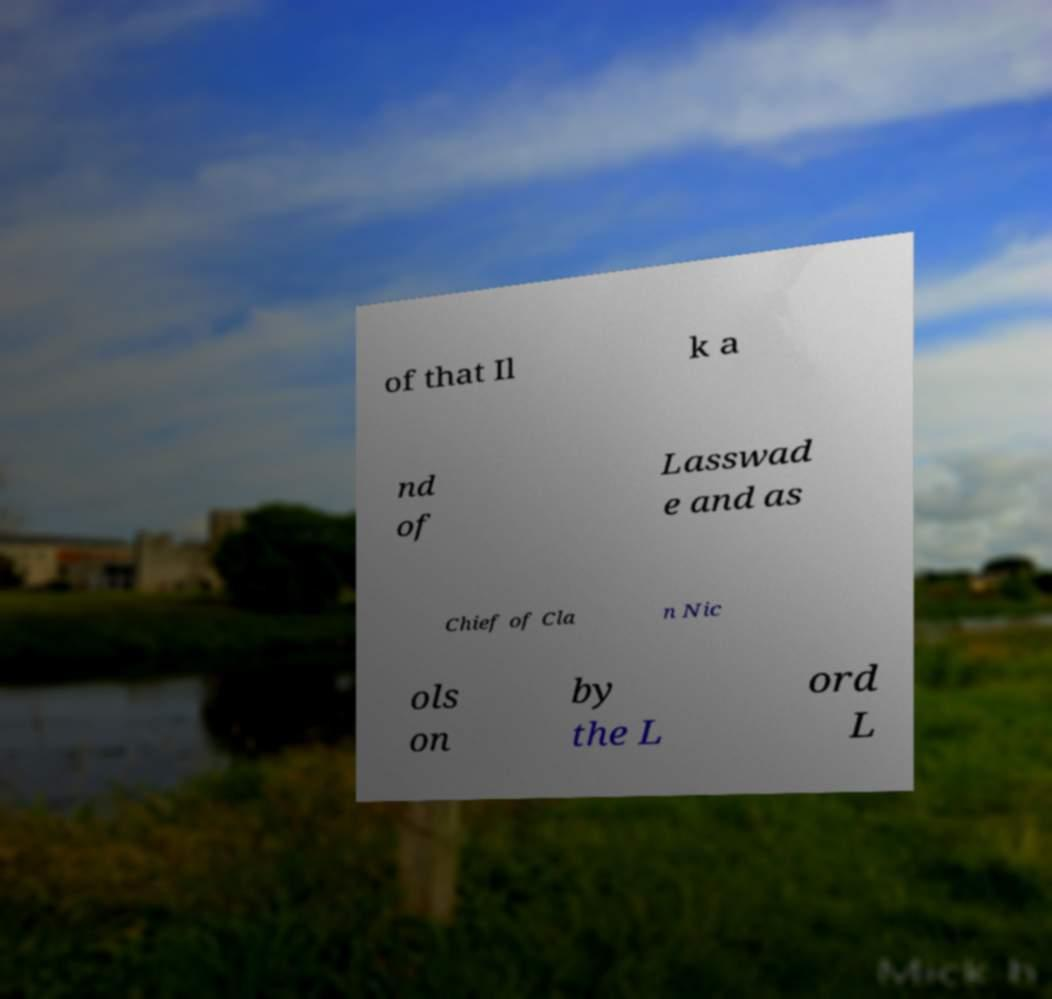I need the written content from this picture converted into text. Can you do that? of that Il k a nd of Lasswad e and as Chief of Cla n Nic ols on by the L ord L 